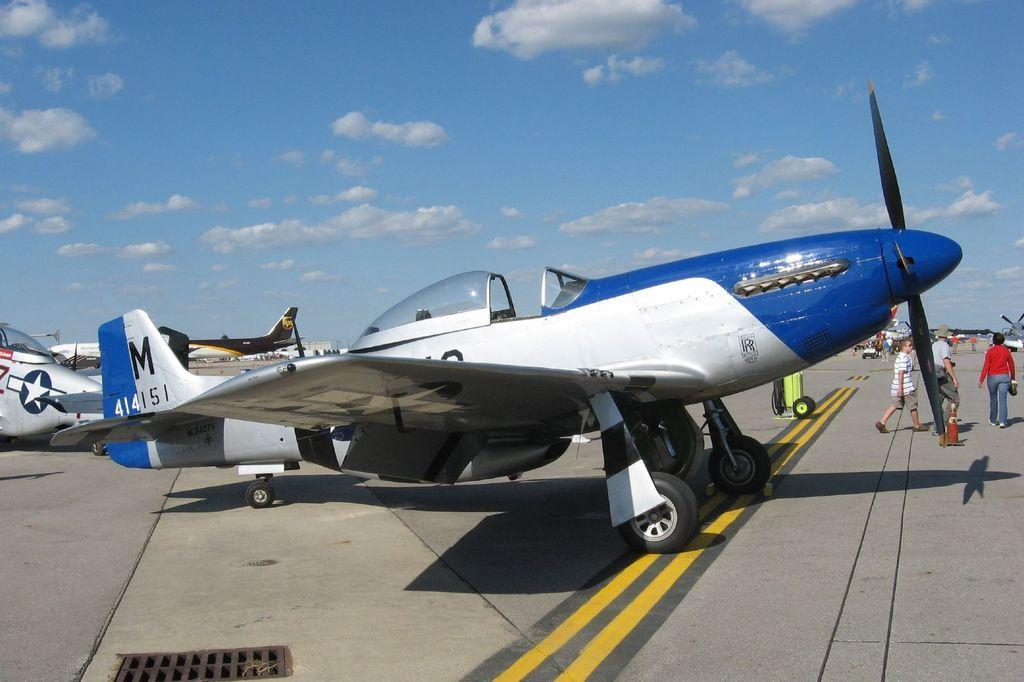What is the main subject of the image? The main subject of the image is a plane. Can you describe the colors of the plane? The plane is blue and silver in color. What is located at the bottom of the image? There is a road at the bottom of the image. What can be seen in the sky at the top of the image? There are clouds in the sky at the top of the image. What are the people in the image doing? The people are walking to the right of the image. What type of map is being used by the plane in the image? There is no map present in the image, and the plane is not shown using any navigational tools. What kind of harmony is being played by the clouds in the image? The clouds in the image are not playing any music or creating any harmony; they are simply clouds in the sky. 